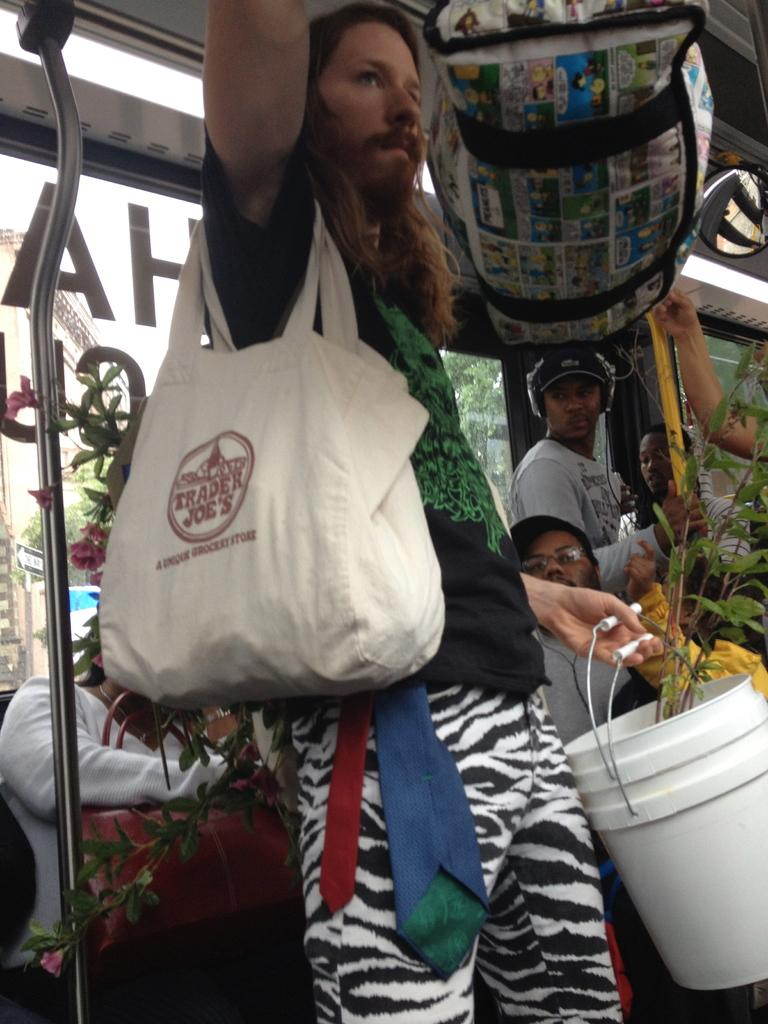What is the man in the image holding in his hand? The man is holding a bag, buckets, and a plant in his hand. What else is the man wearing in the image? The man is wearing a backpack. What are the people in the image doing? There are people seated in the image, and one person is standing and holding a rod. What color is the turkey's eye in the image? There is no turkey present in the image, so it is not possible to answer that question. 